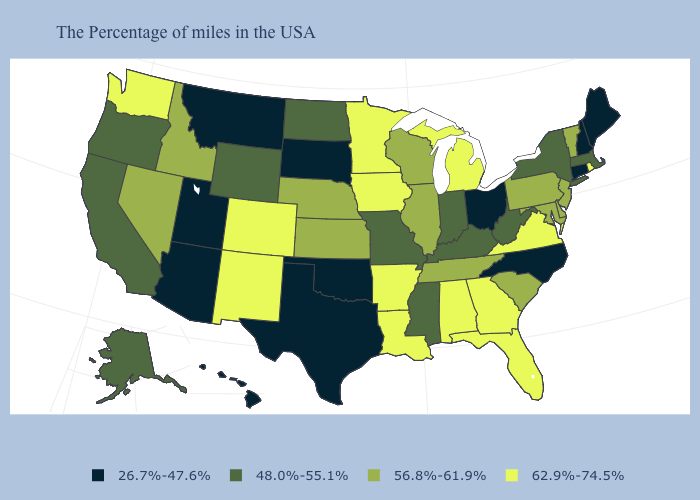What is the value of Illinois?
Answer briefly. 56.8%-61.9%. Name the states that have a value in the range 48.0%-55.1%?
Short answer required. Massachusetts, New York, West Virginia, Kentucky, Indiana, Mississippi, Missouri, North Dakota, Wyoming, California, Oregon, Alaska. What is the highest value in the West ?
Keep it brief. 62.9%-74.5%. What is the value of New York?
Short answer required. 48.0%-55.1%. What is the value of Vermont?
Answer briefly. 56.8%-61.9%. Name the states that have a value in the range 48.0%-55.1%?
Be succinct. Massachusetts, New York, West Virginia, Kentucky, Indiana, Mississippi, Missouri, North Dakota, Wyoming, California, Oregon, Alaska. Among the states that border New Jersey , which have the lowest value?
Concise answer only. New York. Among the states that border Wisconsin , does Illinois have the lowest value?
Be succinct. Yes. Among the states that border Louisiana , does Mississippi have the lowest value?
Be succinct. No. What is the value of Missouri?
Keep it brief. 48.0%-55.1%. What is the value of Iowa?
Quick response, please. 62.9%-74.5%. Name the states that have a value in the range 62.9%-74.5%?
Answer briefly. Rhode Island, Virginia, Florida, Georgia, Michigan, Alabama, Louisiana, Arkansas, Minnesota, Iowa, Colorado, New Mexico, Washington. What is the value of Hawaii?
Write a very short answer. 26.7%-47.6%. Among the states that border Pennsylvania , which have the lowest value?
Be succinct. Ohio. Does West Virginia have the lowest value in the USA?
Concise answer only. No. 